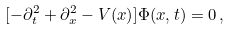Convert formula to latex. <formula><loc_0><loc_0><loc_500><loc_500>[ - \partial ^ { 2 } _ { t } + \partial ^ { 2 } _ { x } - V ( x ) ] \Phi ( x , t ) = 0 \, ,</formula> 